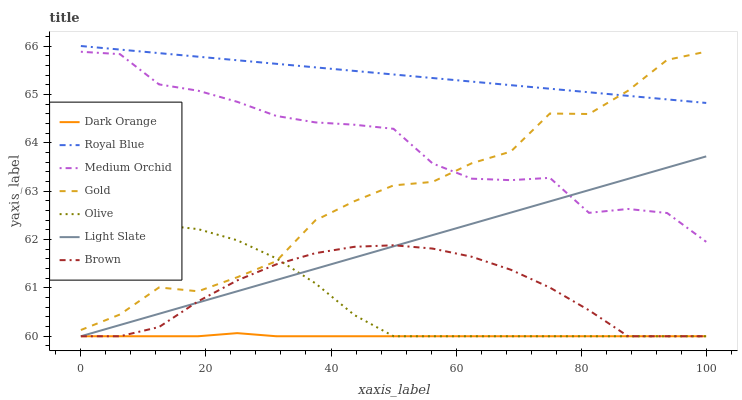Does Dark Orange have the minimum area under the curve?
Answer yes or no. Yes. Does Royal Blue have the maximum area under the curve?
Answer yes or no. Yes. Does Gold have the minimum area under the curve?
Answer yes or no. No. Does Gold have the maximum area under the curve?
Answer yes or no. No. Is Royal Blue the smoothest?
Answer yes or no. Yes. Is Gold the roughest?
Answer yes or no. Yes. Is Brown the smoothest?
Answer yes or no. No. Is Brown the roughest?
Answer yes or no. No. Does Dark Orange have the lowest value?
Answer yes or no. Yes. Does Gold have the lowest value?
Answer yes or no. No. Does Royal Blue have the highest value?
Answer yes or no. Yes. Does Gold have the highest value?
Answer yes or no. No. Is Brown less than Gold?
Answer yes or no. Yes. Is Medium Orchid greater than Dark Orange?
Answer yes or no. Yes. Does Light Slate intersect Olive?
Answer yes or no. Yes. Is Light Slate less than Olive?
Answer yes or no. No. Is Light Slate greater than Olive?
Answer yes or no. No. Does Brown intersect Gold?
Answer yes or no. No. 